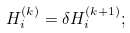Convert formula to latex. <formula><loc_0><loc_0><loc_500><loc_500>H _ { i } ^ { ( k ) } = \delta H _ { i } ^ { ( k + 1 ) } ;</formula> 